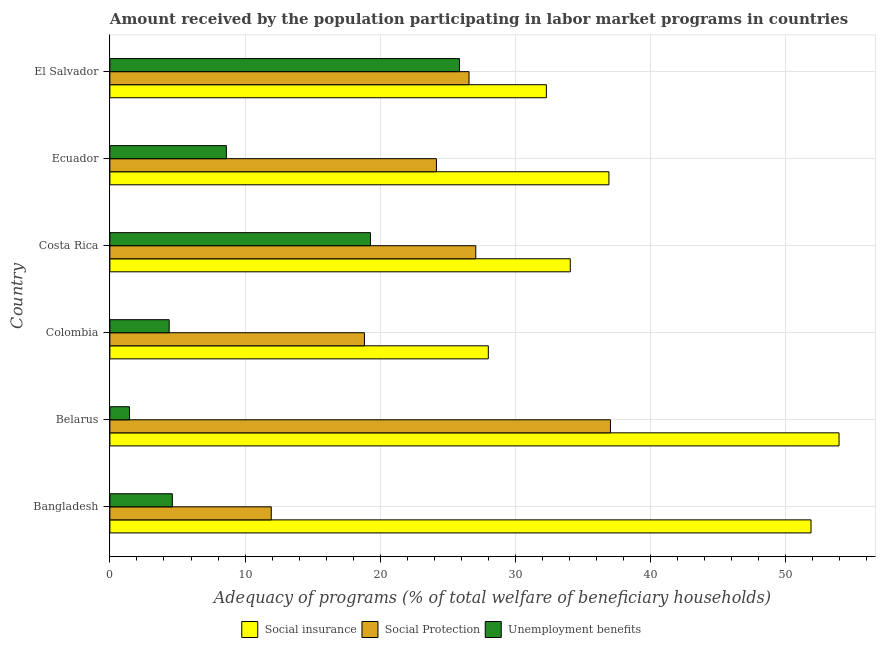How many different coloured bars are there?
Make the answer very short. 3. Are the number of bars per tick equal to the number of legend labels?
Provide a short and direct response. Yes. Are the number of bars on each tick of the Y-axis equal?
Ensure brevity in your answer.  Yes. What is the label of the 2nd group of bars from the top?
Provide a short and direct response. Ecuador. In how many cases, is the number of bars for a given country not equal to the number of legend labels?
Keep it short and to the point. 0. What is the amount received by the population participating in social insurance programs in Belarus?
Your response must be concise. 53.93. Across all countries, what is the maximum amount received by the population participating in social insurance programs?
Your answer should be compact. 53.93. Across all countries, what is the minimum amount received by the population participating in unemployment benefits programs?
Provide a short and direct response. 1.45. In which country was the amount received by the population participating in unemployment benefits programs maximum?
Offer a very short reply. El Salvador. In which country was the amount received by the population participating in social protection programs minimum?
Ensure brevity in your answer.  Bangladesh. What is the total amount received by the population participating in social insurance programs in the graph?
Your response must be concise. 237.04. What is the difference between the amount received by the population participating in social protection programs in Colombia and that in Costa Rica?
Provide a short and direct response. -8.23. What is the difference between the amount received by the population participating in unemployment benefits programs in Costa Rica and the amount received by the population participating in social insurance programs in Colombia?
Offer a terse response. -8.72. What is the average amount received by the population participating in unemployment benefits programs per country?
Offer a terse response. 10.7. What is the difference between the amount received by the population participating in unemployment benefits programs and amount received by the population participating in social insurance programs in Costa Rica?
Provide a succinct answer. -14.78. In how many countries, is the amount received by the population participating in social insurance programs greater than 44 %?
Give a very brief answer. 2. What is the ratio of the amount received by the population participating in social insurance programs in Colombia to that in Ecuador?
Provide a succinct answer. 0.76. Is the amount received by the population participating in social insurance programs in Bangladesh less than that in Ecuador?
Offer a very short reply. No. What is the difference between the highest and the second highest amount received by the population participating in unemployment benefits programs?
Your answer should be very brief. 6.58. What is the difference between the highest and the lowest amount received by the population participating in social insurance programs?
Make the answer very short. 25.94. In how many countries, is the amount received by the population participating in social protection programs greater than the average amount received by the population participating in social protection programs taken over all countries?
Provide a short and direct response. 3. What does the 3rd bar from the top in Costa Rica represents?
Your answer should be compact. Social insurance. What does the 3rd bar from the bottom in Colombia represents?
Offer a very short reply. Unemployment benefits. How many bars are there?
Provide a short and direct response. 18. Are all the bars in the graph horizontal?
Keep it short and to the point. Yes. What is the difference between two consecutive major ticks on the X-axis?
Give a very brief answer. 10. Does the graph contain any zero values?
Give a very brief answer. No. Where does the legend appear in the graph?
Your response must be concise. Bottom center. How are the legend labels stacked?
Your answer should be compact. Horizontal. What is the title of the graph?
Ensure brevity in your answer.  Amount received by the population participating in labor market programs in countries. Does "New Zealand" appear as one of the legend labels in the graph?
Offer a very short reply. No. What is the label or title of the X-axis?
Your response must be concise. Adequacy of programs (% of total welfare of beneficiary households). What is the Adequacy of programs (% of total welfare of beneficiary households) of Social insurance in Bangladesh?
Make the answer very short. 51.86. What is the Adequacy of programs (% of total welfare of beneficiary households) in Social Protection in Bangladesh?
Your answer should be very brief. 11.94. What is the Adequacy of programs (% of total welfare of beneficiary households) of Unemployment benefits in Bangladesh?
Your answer should be very brief. 4.62. What is the Adequacy of programs (% of total welfare of beneficiary households) in Social insurance in Belarus?
Provide a short and direct response. 53.93. What is the Adequacy of programs (% of total welfare of beneficiary households) in Social Protection in Belarus?
Make the answer very short. 37.03. What is the Adequacy of programs (% of total welfare of beneficiary households) in Unemployment benefits in Belarus?
Give a very brief answer. 1.45. What is the Adequacy of programs (% of total welfare of beneficiary households) in Social insurance in Colombia?
Provide a short and direct response. 27.99. What is the Adequacy of programs (% of total welfare of beneficiary households) in Social Protection in Colombia?
Provide a short and direct response. 18.83. What is the Adequacy of programs (% of total welfare of beneficiary households) of Unemployment benefits in Colombia?
Your response must be concise. 4.39. What is the Adequacy of programs (% of total welfare of beneficiary households) of Social insurance in Costa Rica?
Provide a short and direct response. 34.05. What is the Adequacy of programs (% of total welfare of beneficiary households) of Social Protection in Costa Rica?
Make the answer very short. 27.06. What is the Adequacy of programs (% of total welfare of beneficiary households) of Unemployment benefits in Costa Rica?
Offer a very short reply. 19.28. What is the Adequacy of programs (% of total welfare of beneficiary households) in Social insurance in Ecuador?
Your response must be concise. 36.91. What is the Adequacy of programs (% of total welfare of beneficiary households) in Social Protection in Ecuador?
Your answer should be compact. 24.15. What is the Adequacy of programs (% of total welfare of beneficiary households) of Unemployment benefits in Ecuador?
Offer a very short reply. 8.62. What is the Adequacy of programs (% of total welfare of beneficiary households) in Social insurance in El Salvador?
Offer a very short reply. 32.29. What is the Adequacy of programs (% of total welfare of beneficiary households) in Social Protection in El Salvador?
Keep it short and to the point. 26.56. What is the Adequacy of programs (% of total welfare of beneficiary households) of Unemployment benefits in El Salvador?
Ensure brevity in your answer.  25.86. Across all countries, what is the maximum Adequacy of programs (% of total welfare of beneficiary households) in Social insurance?
Keep it short and to the point. 53.93. Across all countries, what is the maximum Adequacy of programs (% of total welfare of beneficiary households) of Social Protection?
Provide a succinct answer. 37.03. Across all countries, what is the maximum Adequacy of programs (% of total welfare of beneficiary households) in Unemployment benefits?
Offer a very short reply. 25.86. Across all countries, what is the minimum Adequacy of programs (% of total welfare of beneficiary households) of Social insurance?
Keep it short and to the point. 27.99. Across all countries, what is the minimum Adequacy of programs (% of total welfare of beneficiary households) in Social Protection?
Your answer should be very brief. 11.94. Across all countries, what is the minimum Adequacy of programs (% of total welfare of beneficiary households) in Unemployment benefits?
Your answer should be compact. 1.45. What is the total Adequacy of programs (% of total welfare of beneficiary households) of Social insurance in the graph?
Provide a succinct answer. 237.04. What is the total Adequacy of programs (% of total welfare of beneficiary households) of Social Protection in the graph?
Your response must be concise. 145.57. What is the total Adequacy of programs (% of total welfare of beneficiary households) in Unemployment benefits in the graph?
Your answer should be compact. 64.21. What is the difference between the Adequacy of programs (% of total welfare of beneficiary households) in Social insurance in Bangladesh and that in Belarus?
Your response must be concise. -2.07. What is the difference between the Adequacy of programs (% of total welfare of beneficiary households) of Social Protection in Bangladesh and that in Belarus?
Ensure brevity in your answer.  -25.09. What is the difference between the Adequacy of programs (% of total welfare of beneficiary households) in Unemployment benefits in Bangladesh and that in Belarus?
Provide a succinct answer. 3.17. What is the difference between the Adequacy of programs (% of total welfare of beneficiary households) in Social insurance in Bangladesh and that in Colombia?
Your response must be concise. 23.87. What is the difference between the Adequacy of programs (% of total welfare of beneficiary households) of Social Protection in Bangladesh and that in Colombia?
Make the answer very short. -6.89. What is the difference between the Adequacy of programs (% of total welfare of beneficiary households) in Unemployment benefits in Bangladesh and that in Colombia?
Make the answer very short. 0.23. What is the difference between the Adequacy of programs (% of total welfare of beneficiary households) of Social insurance in Bangladesh and that in Costa Rica?
Provide a short and direct response. 17.81. What is the difference between the Adequacy of programs (% of total welfare of beneficiary households) of Social Protection in Bangladesh and that in Costa Rica?
Provide a succinct answer. -15.13. What is the difference between the Adequacy of programs (% of total welfare of beneficiary households) of Unemployment benefits in Bangladesh and that in Costa Rica?
Your response must be concise. -14.66. What is the difference between the Adequacy of programs (% of total welfare of beneficiary households) of Social insurance in Bangladesh and that in Ecuador?
Your response must be concise. 14.95. What is the difference between the Adequacy of programs (% of total welfare of beneficiary households) of Social Protection in Bangladesh and that in Ecuador?
Provide a short and direct response. -12.22. What is the difference between the Adequacy of programs (% of total welfare of beneficiary households) in Unemployment benefits in Bangladesh and that in Ecuador?
Your answer should be very brief. -4. What is the difference between the Adequacy of programs (% of total welfare of beneficiary households) in Social insurance in Bangladesh and that in El Salvador?
Offer a terse response. 19.58. What is the difference between the Adequacy of programs (% of total welfare of beneficiary households) in Social Protection in Bangladesh and that in El Salvador?
Your answer should be compact. -14.63. What is the difference between the Adequacy of programs (% of total welfare of beneficiary households) of Unemployment benefits in Bangladesh and that in El Salvador?
Keep it short and to the point. -21.24. What is the difference between the Adequacy of programs (% of total welfare of beneficiary households) in Social insurance in Belarus and that in Colombia?
Your response must be concise. 25.94. What is the difference between the Adequacy of programs (% of total welfare of beneficiary households) of Social Protection in Belarus and that in Colombia?
Keep it short and to the point. 18.2. What is the difference between the Adequacy of programs (% of total welfare of beneficiary households) of Unemployment benefits in Belarus and that in Colombia?
Make the answer very short. -2.94. What is the difference between the Adequacy of programs (% of total welfare of beneficiary households) of Social insurance in Belarus and that in Costa Rica?
Provide a short and direct response. 19.88. What is the difference between the Adequacy of programs (% of total welfare of beneficiary households) of Social Protection in Belarus and that in Costa Rica?
Offer a terse response. 9.96. What is the difference between the Adequacy of programs (% of total welfare of beneficiary households) of Unemployment benefits in Belarus and that in Costa Rica?
Your response must be concise. -17.83. What is the difference between the Adequacy of programs (% of total welfare of beneficiary households) of Social insurance in Belarus and that in Ecuador?
Keep it short and to the point. 17.02. What is the difference between the Adequacy of programs (% of total welfare of beneficiary households) in Social Protection in Belarus and that in Ecuador?
Make the answer very short. 12.87. What is the difference between the Adequacy of programs (% of total welfare of beneficiary households) in Unemployment benefits in Belarus and that in Ecuador?
Keep it short and to the point. -7.17. What is the difference between the Adequacy of programs (% of total welfare of beneficiary households) in Social insurance in Belarus and that in El Salvador?
Your response must be concise. 21.65. What is the difference between the Adequacy of programs (% of total welfare of beneficiary households) of Social Protection in Belarus and that in El Salvador?
Provide a short and direct response. 10.46. What is the difference between the Adequacy of programs (% of total welfare of beneficiary households) of Unemployment benefits in Belarus and that in El Salvador?
Make the answer very short. -24.41. What is the difference between the Adequacy of programs (% of total welfare of beneficiary households) in Social insurance in Colombia and that in Costa Rica?
Make the answer very short. -6.06. What is the difference between the Adequacy of programs (% of total welfare of beneficiary households) in Social Protection in Colombia and that in Costa Rica?
Your answer should be compact. -8.24. What is the difference between the Adequacy of programs (% of total welfare of beneficiary households) of Unemployment benefits in Colombia and that in Costa Rica?
Offer a very short reply. -14.89. What is the difference between the Adequacy of programs (% of total welfare of beneficiary households) of Social insurance in Colombia and that in Ecuador?
Offer a terse response. -8.92. What is the difference between the Adequacy of programs (% of total welfare of beneficiary households) in Social Protection in Colombia and that in Ecuador?
Your answer should be compact. -5.33. What is the difference between the Adequacy of programs (% of total welfare of beneficiary households) in Unemployment benefits in Colombia and that in Ecuador?
Your response must be concise. -4.23. What is the difference between the Adequacy of programs (% of total welfare of beneficiary households) in Social insurance in Colombia and that in El Salvador?
Provide a succinct answer. -4.29. What is the difference between the Adequacy of programs (% of total welfare of beneficiary households) of Social Protection in Colombia and that in El Salvador?
Give a very brief answer. -7.74. What is the difference between the Adequacy of programs (% of total welfare of beneficiary households) in Unemployment benefits in Colombia and that in El Salvador?
Provide a short and direct response. -21.47. What is the difference between the Adequacy of programs (% of total welfare of beneficiary households) in Social insurance in Costa Rica and that in Ecuador?
Ensure brevity in your answer.  -2.86. What is the difference between the Adequacy of programs (% of total welfare of beneficiary households) of Social Protection in Costa Rica and that in Ecuador?
Give a very brief answer. 2.91. What is the difference between the Adequacy of programs (% of total welfare of beneficiary households) in Unemployment benefits in Costa Rica and that in Ecuador?
Ensure brevity in your answer.  10.66. What is the difference between the Adequacy of programs (% of total welfare of beneficiary households) in Social insurance in Costa Rica and that in El Salvador?
Provide a short and direct response. 1.77. What is the difference between the Adequacy of programs (% of total welfare of beneficiary households) of Social Protection in Costa Rica and that in El Salvador?
Provide a succinct answer. 0.5. What is the difference between the Adequacy of programs (% of total welfare of beneficiary households) of Unemployment benefits in Costa Rica and that in El Salvador?
Your answer should be compact. -6.58. What is the difference between the Adequacy of programs (% of total welfare of beneficiary households) of Social insurance in Ecuador and that in El Salvador?
Make the answer very short. 4.63. What is the difference between the Adequacy of programs (% of total welfare of beneficiary households) in Social Protection in Ecuador and that in El Salvador?
Your answer should be compact. -2.41. What is the difference between the Adequacy of programs (% of total welfare of beneficiary households) of Unemployment benefits in Ecuador and that in El Salvador?
Provide a succinct answer. -17.24. What is the difference between the Adequacy of programs (% of total welfare of beneficiary households) in Social insurance in Bangladesh and the Adequacy of programs (% of total welfare of beneficiary households) in Social Protection in Belarus?
Make the answer very short. 14.84. What is the difference between the Adequacy of programs (% of total welfare of beneficiary households) of Social insurance in Bangladesh and the Adequacy of programs (% of total welfare of beneficiary households) of Unemployment benefits in Belarus?
Your answer should be compact. 50.41. What is the difference between the Adequacy of programs (% of total welfare of beneficiary households) in Social Protection in Bangladesh and the Adequacy of programs (% of total welfare of beneficiary households) in Unemployment benefits in Belarus?
Keep it short and to the point. 10.49. What is the difference between the Adequacy of programs (% of total welfare of beneficiary households) of Social insurance in Bangladesh and the Adequacy of programs (% of total welfare of beneficiary households) of Social Protection in Colombia?
Offer a terse response. 33.03. What is the difference between the Adequacy of programs (% of total welfare of beneficiary households) of Social insurance in Bangladesh and the Adequacy of programs (% of total welfare of beneficiary households) of Unemployment benefits in Colombia?
Your answer should be very brief. 47.48. What is the difference between the Adequacy of programs (% of total welfare of beneficiary households) of Social Protection in Bangladesh and the Adequacy of programs (% of total welfare of beneficiary households) of Unemployment benefits in Colombia?
Offer a very short reply. 7.55. What is the difference between the Adequacy of programs (% of total welfare of beneficiary households) in Social insurance in Bangladesh and the Adequacy of programs (% of total welfare of beneficiary households) in Social Protection in Costa Rica?
Your response must be concise. 24.8. What is the difference between the Adequacy of programs (% of total welfare of beneficiary households) in Social insurance in Bangladesh and the Adequacy of programs (% of total welfare of beneficiary households) in Unemployment benefits in Costa Rica?
Ensure brevity in your answer.  32.59. What is the difference between the Adequacy of programs (% of total welfare of beneficiary households) of Social Protection in Bangladesh and the Adequacy of programs (% of total welfare of beneficiary households) of Unemployment benefits in Costa Rica?
Your response must be concise. -7.34. What is the difference between the Adequacy of programs (% of total welfare of beneficiary households) of Social insurance in Bangladesh and the Adequacy of programs (% of total welfare of beneficiary households) of Social Protection in Ecuador?
Provide a succinct answer. 27.71. What is the difference between the Adequacy of programs (% of total welfare of beneficiary households) in Social insurance in Bangladesh and the Adequacy of programs (% of total welfare of beneficiary households) in Unemployment benefits in Ecuador?
Your answer should be very brief. 43.24. What is the difference between the Adequacy of programs (% of total welfare of beneficiary households) of Social Protection in Bangladesh and the Adequacy of programs (% of total welfare of beneficiary households) of Unemployment benefits in Ecuador?
Your response must be concise. 3.32. What is the difference between the Adequacy of programs (% of total welfare of beneficiary households) in Social insurance in Bangladesh and the Adequacy of programs (% of total welfare of beneficiary households) in Social Protection in El Salvador?
Give a very brief answer. 25.3. What is the difference between the Adequacy of programs (% of total welfare of beneficiary households) of Social insurance in Bangladesh and the Adequacy of programs (% of total welfare of beneficiary households) of Unemployment benefits in El Salvador?
Your response must be concise. 26. What is the difference between the Adequacy of programs (% of total welfare of beneficiary households) in Social Protection in Bangladesh and the Adequacy of programs (% of total welfare of beneficiary households) in Unemployment benefits in El Salvador?
Offer a terse response. -13.92. What is the difference between the Adequacy of programs (% of total welfare of beneficiary households) in Social insurance in Belarus and the Adequacy of programs (% of total welfare of beneficiary households) in Social Protection in Colombia?
Your answer should be very brief. 35.1. What is the difference between the Adequacy of programs (% of total welfare of beneficiary households) in Social insurance in Belarus and the Adequacy of programs (% of total welfare of beneficiary households) in Unemployment benefits in Colombia?
Your response must be concise. 49.55. What is the difference between the Adequacy of programs (% of total welfare of beneficiary households) in Social Protection in Belarus and the Adequacy of programs (% of total welfare of beneficiary households) in Unemployment benefits in Colombia?
Ensure brevity in your answer.  32.64. What is the difference between the Adequacy of programs (% of total welfare of beneficiary households) in Social insurance in Belarus and the Adequacy of programs (% of total welfare of beneficiary households) in Social Protection in Costa Rica?
Keep it short and to the point. 26.87. What is the difference between the Adequacy of programs (% of total welfare of beneficiary households) of Social insurance in Belarus and the Adequacy of programs (% of total welfare of beneficiary households) of Unemployment benefits in Costa Rica?
Give a very brief answer. 34.66. What is the difference between the Adequacy of programs (% of total welfare of beneficiary households) in Social Protection in Belarus and the Adequacy of programs (% of total welfare of beneficiary households) in Unemployment benefits in Costa Rica?
Provide a short and direct response. 17.75. What is the difference between the Adequacy of programs (% of total welfare of beneficiary households) of Social insurance in Belarus and the Adequacy of programs (% of total welfare of beneficiary households) of Social Protection in Ecuador?
Provide a short and direct response. 29.78. What is the difference between the Adequacy of programs (% of total welfare of beneficiary households) in Social insurance in Belarus and the Adequacy of programs (% of total welfare of beneficiary households) in Unemployment benefits in Ecuador?
Make the answer very short. 45.32. What is the difference between the Adequacy of programs (% of total welfare of beneficiary households) in Social Protection in Belarus and the Adequacy of programs (% of total welfare of beneficiary households) in Unemployment benefits in Ecuador?
Provide a short and direct response. 28.41. What is the difference between the Adequacy of programs (% of total welfare of beneficiary households) of Social insurance in Belarus and the Adequacy of programs (% of total welfare of beneficiary households) of Social Protection in El Salvador?
Give a very brief answer. 27.37. What is the difference between the Adequacy of programs (% of total welfare of beneficiary households) in Social insurance in Belarus and the Adequacy of programs (% of total welfare of beneficiary households) in Unemployment benefits in El Salvador?
Ensure brevity in your answer.  28.08. What is the difference between the Adequacy of programs (% of total welfare of beneficiary households) of Social Protection in Belarus and the Adequacy of programs (% of total welfare of beneficiary households) of Unemployment benefits in El Salvador?
Provide a short and direct response. 11.17. What is the difference between the Adequacy of programs (% of total welfare of beneficiary households) of Social insurance in Colombia and the Adequacy of programs (% of total welfare of beneficiary households) of Social Protection in Costa Rica?
Your response must be concise. 0.93. What is the difference between the Adequacy of programs (% of total welfare of beneficiary households) in Social insurance in Colombia and the Adequacy of programs (% of total welfare of beneficiary households) in Unemployment benefits in Costa Rica?
Provide a short and direct response. 8.72. What is the difference between the Adequacy of programs (% of total welfare of beneficiary households) of Social Protection in Colombia and the Adequacy of programs (% of total welfare of beneficiary households) of Unemployment benefits in Costa Rica?
Provide a short and direct response. -0.45. What is the difference between the Adequacy of programs (% of total welfare of beneficiary households) of Social insurance in Colombia and the Adequacy of programs (% of total welfare of beneficiary households) of Social Protection in Ecuador?
Make the answer very short. 3.84. What is the difference between the Adequacy of programs (% of total welfare of beneficiary households) in Social insurance in Colombia and the Adequacy of programs (% of total welfare of beneficiary households) in Unemployment benefits in Ecuador?
Offer a very short reply. 19.37. What is the difference between the Adequacy of programs (% of total welfare of beneficiary households) in Social Protection in Colombia and the Adequacy of programs (% of total welfare of beneficiary households) in Unemployment benefits in Ecuador?
Provide a short and direct response. 10.21. What is the difference between the Adequacy of programs (% of total welfare of beneficiary households) of Social insurance in Colombia and the Adequacy of programs (% of total welfare of beneficiary households) of Social Protection in El Salvador?
Give a very brief answer. 1.43. What is the difference between the Adequacy of programs (% of total welfare of beneficiary households) of Social insurance in Colombia and the Adequacy of programs (% of total welfare of beneficiary households) of Unemployment benefits in El Salvador?
Offer a terse response. 2.13. What is the difference between the Adequacy of programs (% of total welfare of beneficiary households) of Social Protection in Colombia and the Adequacy of programs (% of total welfare of beneficiary households) of Unemployment benefits in El Salvador?
Offer a terse response. -7.03. What is the difference between the Adequacy of programs (% of total welfare of beneficiary households) in Social insurance in Costa Rica and the Adequacy of programs (% of total welfare of beneficiary households) in Social Protection in Ecuador?
Provide a short and direct response. 9.9. What is the difference between the Adequacy of programs (% of total welfare of beneficiary households) in Social insurance in Costa Rica and the Adequacy of programs (% of total welfare of beneficiary households) in Unemployment benefits in Ecuador?
Ensure brevity in your answer.  25.44. What is the difference between the Adequacy of programs (% of total welfare of beneficiary households) in Social Protection in Costa Rica and the Adequacy of programs (% of total welfare of beneficiary households) in Unemployment benefits in Ecuador?
Your answer should be compact. 18.45. What is the difference between the Adequacy of programs (% of total welfare of beneficiary households) of Social insurance in Costa Rica and the Adequacy of programs (% of total welfare of beneficiary households) of Social Protection in El Salvador?
Give a very brief answer. 7.49. What is the difference between the Adequacy of programs (% of total welfare of beneficiary households) in Social insurance in Costa Rica and the Adequacy of programs (% of total welfare of beneficiary households) in Unemployment benefits in El Salvador?
Give a very brief answer. 8.2. What is the difference between the Adequacy of programs (% of total welfare of beneficiary households) in Social Protection in Costa Rica and the Adequacy of programs (% of total welfare of beneficiary households) in Unemployment benefits in El Salvador?
Ensure brevity in your answer.  1.21. What is the difference between the Adequacy of programs (% of total welfare of beneficiary households) of Social insurance in Ecuador and the Adequacy of programs (% of total welfare of beneficiary households) of Social Protection in El Salvador?
Your answer should be very brief. 10.35. What is the difference between the Adequacy of programs (% of total welfare of beneficiary households) in Social insurance in Ecuador and the Adequacy of programs (% of total welfare of beneficiary households) in Unemployment benefits in El Salvador?
Ensure brevity in your answer.  11.05. What is the difference between the Adequacy of programs (% of total welfare of beneficiary households) of Social Protection in Ecuador and the Adequacy of programs (% of total welfare of beneficiary households) of Unemployment benefits in El Salvador?
Offer a very short reply. -1.7. What is the average Adequacy of programs (% of total welfare of beneficiary households) in Social insurance per country?
Offer a very short reply. 39.51. What is the average Adequacy of programs (% of total welfare of beneficiary households) of Social Protection per country?
Your answer should be very brief. 24.26. What is the average Adequacy of programs (% of total welfare of beneficiary households) of Unemployment benefits per country?
Keep it short and to the point. 10.7. What is the difference between the Adequacy of programs (% of total welfare of beneficiary households) of Social insurance and Adequacy of programs (% of total welfare of beneficiary households) of Social Protection in Bangladesh?
Your response must be concise. 39.92. What is the difference between the Adequacy of programs (% of total welfare of beneficiary households) of Social insurance and Adequacy of programs (% of total welfare of beneficiary households) of Unemployment benefits in Bangladesh?
Provide a short and direct response. 47.24. What is the difference between the Adequacy of programs (% of total welfare of beneficiary households) in Social Protection and Adequacy of programs (% of total welfare of beneficiary households) in Unemployment benefits in Bangladesh?
Offer a terse response. 7.32. What is the difference between the Adequacy of programs (% of total welfare of beneficiary households) of Social insurance and Adequacy of programs (% of total welfare of beneficiary households) of Social Protection in Belarus?
Your answer should be compact. 16.91. What is the difference between the Adequacy of programs (% of total welfare of beneficiary households) of Social insurance and Adequacy of programs (% of total welfare of beneficiary households) of Unemployment benefits in Belarus?
Give a very brief answer. 52.48. What is the difference between the Adequacy of programs (% of total welfare of beneficiary households) in Social Protection and Adequacy of programs (% of total welfare of beneficiary households) in Unemployment benefits in Belarus?
Ensure brevity in your answer.  35.58. What is the difference between the Adequacy of programs (% of total welfare of beneficiary households) of Social insurance and Adequacy of programs (% of total welfare of beneficiary households) of Social Protection in Colombia?
Make the answer very short. 9.16. What is the difference between the Adequacy of programs (% of total welfare of beneficiary households) in Social insurance and Adequacy of programs (% of total welfare of beneficiary households) in Unemployment benefits in Colombia?
Your answer should be very brief. 23.61. What is the difference between the Adequacy of programs (% of total welfare of beneficiary households) of Social Protection and Adequacy of programs (% of total welfare of beneficiary households) of Unemployment benefits in Colombia?
Your answer should be compact. 14.44. What is the difference between the Adequacy of programs (% of total welfare of beneficiary households) of Social insurance and Adequacy of programs (% of total welfare of beneficiary households) of Social Protection in Costa Rica?
Give a very brief answer. 6.99. What is the difference between the Adequacy of programs (% of total welfare of beneficiary households) of Social insurance and Adequacy of programs (% of total welfare of beneficiary households) of Unemployment benefits in Costa Rica?
Ensure brevity in your answer.  14.78. What is the difference between the Adequacy of programs (% of total welfare of beneficiary households) of Social Protection and Adequacy of programs (% of total welfare of beneficiary households) of Unemployment benefits in Costa Rica?
Provide a succinct answer. 7.79. What is the difference between the Adequacy of programs (% of total welfare of beneficiary households) in Social insurance and Adequacy of programs (% of total welfare of beneficiary households) in Social Protection in Ecuador?
Offer a terse response. 12.76. What is the difference between the Adequacy of programs (% of total welfare of beneficiary households) in Social insurance and Adequacy of programs (% of total welfare of beneficiary households) in Unemployment benefits in Ecuador?
Your response must be concise. 28.3. What is the difference between the Adequacy of programs (% of total welfare of beneficiary households) in Social Protection and Adequacy of programs (% of total welfare of beneficiary households) in Unemployment benefits in Ecuador?
Offer a terse response. 15.54. What is the difference between the Adequacy of programs (% of total welfare of beneficiary households) of Social insurance and Adequacy of programs (% of total welfare of beneficiary households) of Social Protection in El Salvador?
Offer a very short reply. 5.72. What is the difference between the Adequacy of programs (% of total welfare of beneficiary households) in Social insurance and Adequacy of programs (% of total welfare of beneficiary households) in Unemployment benefits in El Salvador?
Ensure brevity in your answer.  6.43. What is the difference between the Adequacy of programs (% of total welfare of beneficiary households) of Social Protection and Adequacy of programs (% of total welfare of beneficiary households) of Unemployment benefits in El Salvador?
Your response must be concise. 0.71. What is the ratio of the Adequacy of programs (% of total welfare of beneficiary households) of Social insurance in Bangladesh to that in Belarus?
Make the answer very short. 0.96. What is the ratio of the Adequacy of programs (% of total welfare of beneficiary households) of Social Protection in Bangladesh to that in Belarus?
Provide a succinct answer. 0.32. What is the ratio of the Adequacy of programs (% of total welfare of beneficiary households) of Unemployment benefits in Bangladesh to that in Belarus?
Your answer should be compact. 3.19. What is the ratio of the Adequacy of programs (% of total welfare of beneficiary households) in Social insurance in Bangladesh to that in Colombia?
Offer a very short reply. 1.85. What is the ratio of the Adequacy of programs (% of total welfare of beneficiary households) of Social Protection in Bangladesh to that in Colombia?
Provide a short and direct response. 0.63. What is the ratio of the Adequacy of programs (% of total welfare of beneficiary households) in Unemployment benefits in Bangladesh to that in Colombia?
Make the answer very short. 1.05. What is the ratio of the Adequacy of programs (% of total welfare of beneficiary households) of Social insurance in Bangladesh to that in Costa Rica?
Make the answer very short. 1.52. What is the ratio of the Adequacy of programs (% of total welfare of beneficiary households) of Social Protection in Bangladesh to that in Costa Rica?
Provide a short and direct response. 0.44. What is the ratio of the Adequacy of programs (% of total welfare of beneficiary households) of Unemployment benefits in Bangladesh to that in Costa Rica?
Provide a succinct answer. 0.24. What is the ratio of the Adequacy of programs (% of total welfare of beneficiary households) of Social insurance in Bangladesh to that in Ecuador?
Provide a succinct answer. 1.41. What is the ratio of the Adequacy of programs (% of total welfare of beneficiary households) in Social Protection in Bangladesh to that in Ecuador?
Your answer should be very brief. 0.49. What is the ratio of the Adequacy of programs (% of total welfare of beneficiary households) in Unemployment benefits in Bangladesh to that in Ecuador?
Offer a very short reply. 0.54. What is the ratio of the Adequacy of programs (% of total welfare of beneficiary households) in Social insurance in Bangladesh to that in El Salvador?
Offer a terse response. 1.61. What is the ratio of the Adequacy of programs (% of total welfare of beneficiary households) of Social Protection in Bangladesh to that in El Salvador?
Provide a succinct answer. 0.45. What is the ratio of the Adequacy of programs (% of total welfare of beneficiary households) of Unemployment benefits in Bangladesh to that in El Salvador?
Ensure brevity in your answer.  0.18. What is the ratio of the Adequacy of programs (% of total welfare of beneficiary households) in Social insurance in Belarus to that in Colombia?
Offer a very short reply. 1.93. What is the ratio of the Adequacy of programs (% of total welfare of beneficiary households) of Social Protection in Belarus to that in Colombia?
Your answer should be compact. 1.97. What is the ratio of the Adequacy of programs (% of total welfare of beneficiary households) in Unemployment benefits in Belarus to that in Colombia?
Keep it short and to the point. 0.33. What is the ratio of the Adequacy of programs (% of total welfare of beneficiary households) in Social insurance in Belarus to that in Costa Rica?
Make the answer very short. 1.58. What is the ratio of the Adequacy of programs (% of total welfare of beneficiary households) of Social Protection in Belarus to that in Costa Rica?
Ensure brevity in your answer.  1.37. What is the ratio of the Adequacy of programs (% of total welfare of beneficiary households) in Unemployment benefits in Belarus to that in Costa Rica?
Offer a very short reply. 0.08. What is the ratio of the Adequacy of programs (% of total welfare of beneficiary households) in Social insurance in Belarus to that in Ecuador?
Ensure brevity in your answer.  1.46. What is the ratio of the Adequacy of programs (% of total welfare of beneficiary households) of Social Protection in Belarus to that in Ecuador?
Give a very brief answer. 1.53. What is the ratio of the Adequacy of programs (% of total welfare of beneficiary households) of Unemployment benefits in Belarus to that in Ecuador?
Make the answer very short. 0.17. What is the ratio of the Adequacy of programs (% of total welfare of beneficiary households) in Social insurance in Belarus to that in El Salvador?
Make the answer very short. 1.67. What is the ratio of the Adequacy of programs (% of total welfare of beneficiary households) in Social Protection in Belarus to that in El Salvador?
Give a very brief answer. 1.39. What is the ratio of the Adequacy of programs (% of total welfare of beneficiary households) in Unemployment benefits in Belarus to that in El Salvador?
Keep it short and to the point. 0.06. What is the ratio of the Adequacy of programs (% of total welfare of beneficiary households) of Social insurance in Colombia to that in Costa Rica?
Give a very brief answer. 0.82. What is the ratio of the Adequacy of programs (% of total welfare of beneficiary households) in Social Protection in Colombia to that in Costa Rica?
Your answer should be very brief. 0.7. What is the ratio of the Adequacy of programs (% of total welfare of beneficiary households) in Unemployment benefits in Colombia to that in Costa Rica?
Your response must be concise. 0.23. What is the ratio of the Adequacy of programs (% of total welfare of beneficiary households) in Social insurance in Colombia to that in Ecuador?
Give a very brief answer. 0.76. What is the ratio of the Adequacy of programs (% of total welfare of beneficiary households) in Social Protection in Colombia to that in Ecuador?
Your answer should be compact. 0.78. What is the ratio of the Adequacy of programs (% of total welfare of beneficiary households) in Unemployment benefits in Colombia to that in Ecuador?
Make the answer very short. 0.51. What is the ratio of the Adequacy of programs (% of total welfare of beneficiary households) of Social insurance in Colombia to that in El Salvador?
Make the answer very short. 0.87. What is the ratio of the Adequacy of programs (% of total welfare of beneficiary households) in Social Protection in Colombia to that in El Salvador?
Your answer should be very brief. 0.71. What is the ratio of the Adequacy of programs (% of total welfare of beneficiary households) of Unemployment benefits in Colombia to that in El Salvador?
Keep it short and to the point. 0.17. What is the ratio of the Adequacy of programs (% of total welfare of beneficiary households) of Social insurance in Costa Rica to that in Ecuador?
Provide a succinct answer. 0.92. What is the ratio of the Adequacy of programs (% of total welfare of beneficiary households) in Social Protection in Costa Rica to that in Ecuador?
Give a very brief answer. 1.12. What is the ratio of the Adequacy of programs (% of total welfare of beneficiary households) of Unemployment benefits in Costa Rica to that in Ecuador?
Offer a terse response. 2.24. What is the ratio of the Adequacy of programs (% of total welfare of beneficiary households) of Social insurance in Costa Rica to that in El Salvador?
Offer a very short reply. 1.05. What is the ratio of the Adequacy of programs (% of total welfare of beneficiary households) in Social Protection in Costa Rica to that in El Salvador?
Ensure brevity in your answer.  1.02. What is the ratio of the Adequacy of programs (% of total welfare of beneficiary households) in Unemployment benefits in Costa Rica to that in El Salvador?
Keep it short and to the point. 0.75. What is the ratio of the Adequacy of programs (% of total welfare of beneficiary households) in Social insurance in Ecuador to that in El Salvador?
Ensure brevity in your answer.  1.14. What is the ratio of the Adequacy of programs (% of total welfare of beneficiary households) in Social Protection in Ecuador to that in El Salvador?
Your answer should be very brief. 0.91. What is the ratio of the Adequacy of programs (% of total welfare of beneficiary households) in Unemployment benefits in Ecuador to that in El Salvador?
Keep it short and to the point. 0.33. What is the difference between the highest and the second highest Adequacy of programs (% of total welfare of beneficiary households) in Social insurance?
Your answer should be very brief. 2.07. What is the difference between the highest and the second highest Adequacy of programs (% of total welfare of beneficiary households) of Social Protection?
Provide a short and direct response. 9.96. What is the difference between the highest and the second highest Adequacy of programs (% of total welfare of beneficiary households) of Unemployment benefits?
Ensure brevity in your answer.  6.58. What is the difference between the highest and the lowest Adequacy of programs (% of total welfare of beneficiary households) of Social insurance?
Give a very brief answer. 25.94. What is the difference between the highest and the lowest Adequacy of programs (% of total welfare of beneficiary households) of Social Protection?
Offer a very short reply. 25.09. What is the difference between the highest and the lowest Adequacy of programs (% of total welfare of beneficiary households) in Unemployment benefits?
Ensure brevity in your answer.  24.41. 